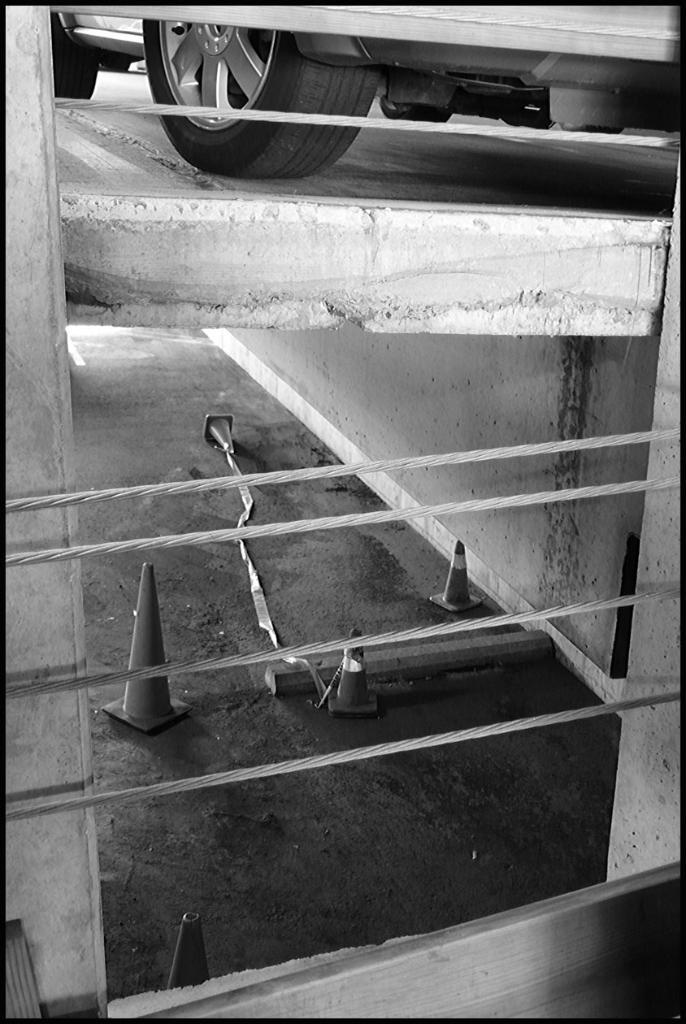What is the main subject of the image? There is a vehicle in the image. Where is the vehicle located in the image? The vehicle is at the top of the image. What else can be seen in the image besides the vehicle? There are walls, road safety cones, and cables in the image. What type of science experiment is the goat conducting in the image? There is no goat or science experiment present in the image. 